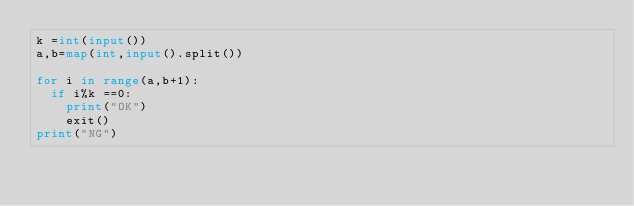Convert code to text. <code><loc_0><loc_0><loc_500><loc_500><_Python_>k =int(input())
a,b=map(int,input().split())

for i in range(a,b+1):
  if i%k ==0:
    print("OK")
    exit()
print("NG")</code> 